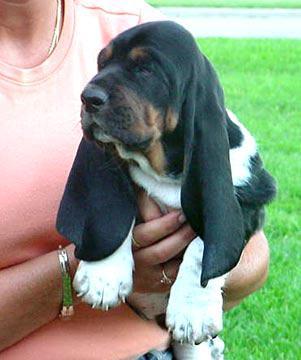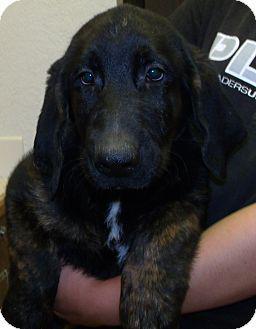The first image is the image on the left, the second image is the image on the right. Considering the images on both sides, is "One of the dogs is sitting on or lying next to a pillow." valid? Answer yes or no. No. 